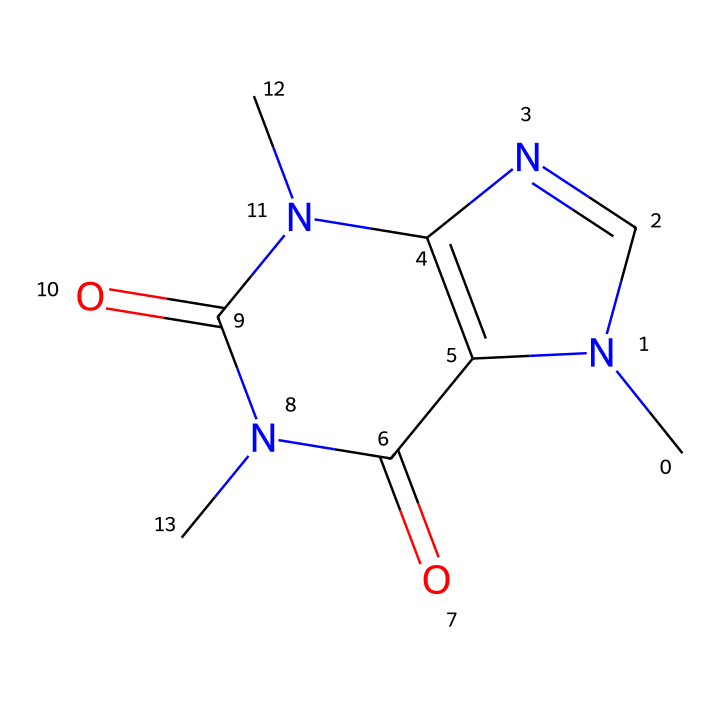What is the molecular formula of caffeine? By analyzing the SMILES representation, we can count the number of each type of atom: there are 8 carbon (C), 10 hydrogen (H), 4 nitrogen (N), and 2 oxygen (O) atoms. Thus, the molecular formula is constructed as C8H10N4O2.
Answer: C8H10N4O2 How many nitrogen atoms are in the structure? The SMILES that represents caffeine indicates the presence of four nitrogen atoms. We can see them designated by the 'N' symbols within the structure.
Answer: 4 What type of compound is caffeine classified as? Caffeine is classified as a methylxanthine, which is a subtype of xanthines due to its structure featuring both uric acid and dimethylated groups. Observing the nitrogen atoms reflects the structure of these compounds.
Answer: methylxanthine What is the number of rings in the structure? The analysis of the structure reveals that it contains two fused rings. We see that these rings are formed through specific connections between nitrogen and carbon atoms throughout the SMILES representation.
Answer: 2 What is the significance of the nitrogen atoms in caffeine? The presence of nitrogen atoms in caffeine is significant as they contribute to its pharmacological effects. Nitrogen atoms are part of the alkaloid structure, which is responsible for its stimulating effects on the central nervous system.
Answer: stimulating effects What kind of cage structure does caffeine possess? Caffeine exhibits a bicyclic structure, which is characteristic of cage compounds. The interconnected rings form a two-ring system that fits the definition of a cage structure, connecting multiple atoms.
Answer: bicyclic structure 